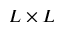Convert formula to latex. <formula><loc_0><loc_0><loc_500><loc_500>L \times L</formula> 